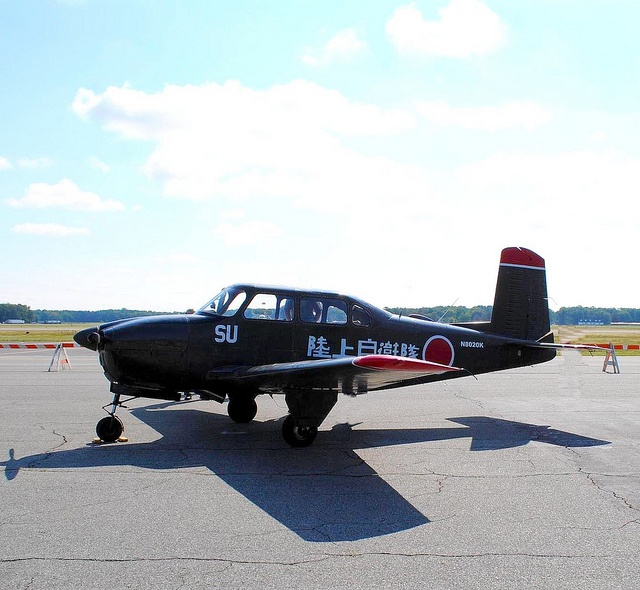Describe the objects in this image and their specific colors. I can see a airplane in lightblue, black, lightgray, darkgray, and navy tones in this image. 